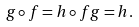<formula> <loc_0><loc_0><loc_500><loc_500>g \circ f = h \circ f g = h .</formula> 